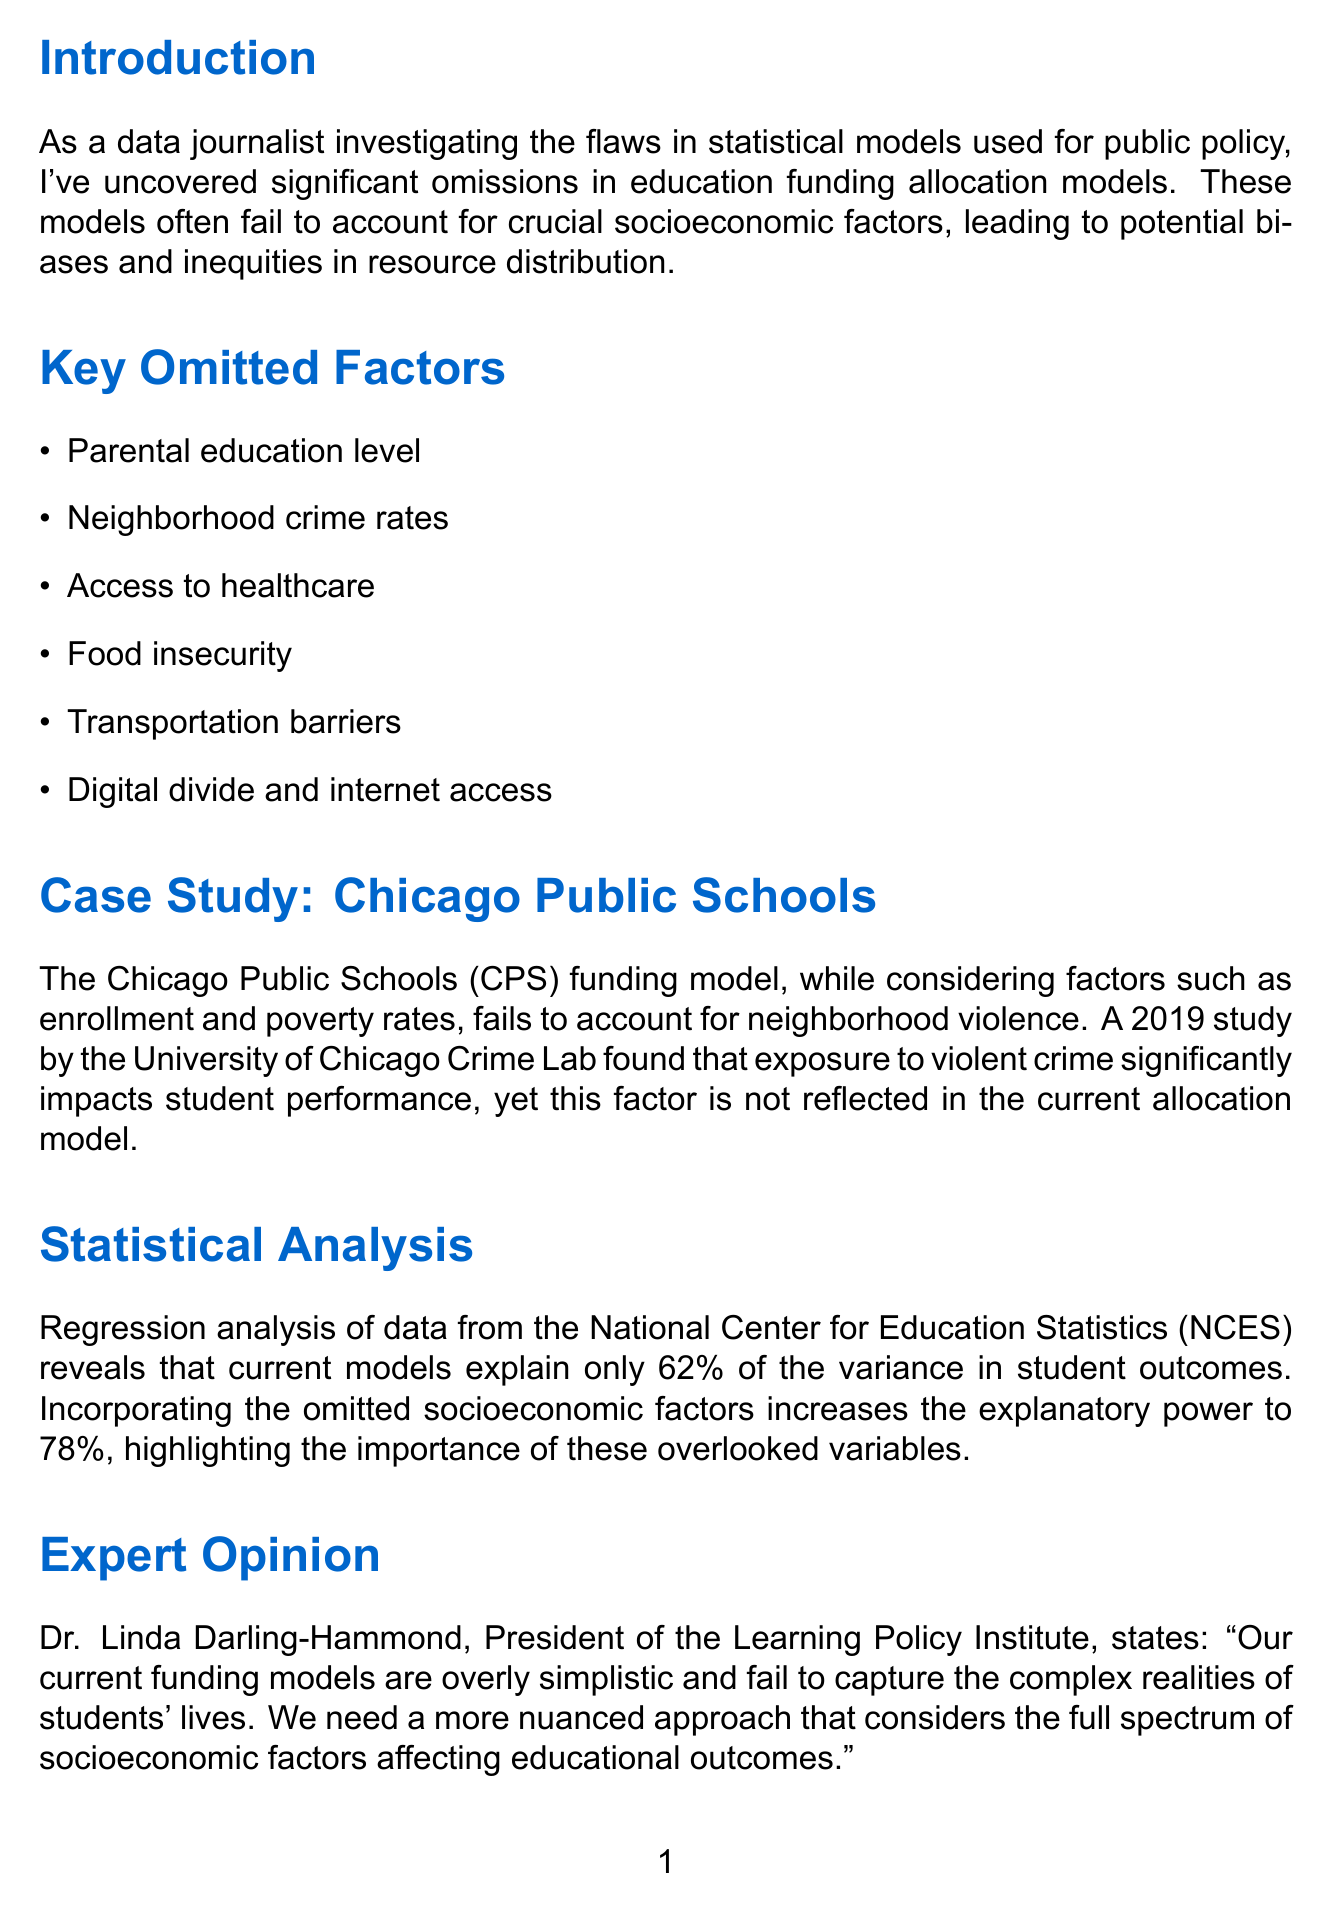what is the title of the document? The title is stated at the top of the document, indicating the main focus of the memo.
Answer: Examination of Socioeconomic Factors Omitted from Education Funding Allocation Models how many key omitted factors are listed? The document enumerates various omitted factors in a specific section, allowing for easy counting.
Answer: Six which case study is presented in the memo? The case study mentioned focuses on a specific educational institution to illustrate the points made.
Answer: Chicago Public Schools what percentage of variance in student outcomes do current models explain? This information is provided in the statistical analysis section of the document, giving a specific evaluation of the models.
Answer: 62% who is the expert quoted in the document? The memo attributes an opinion to a notable authority in education, lending credibility to its claims.
Answer: Dr. Linda Darling-Hammond what is one of the potential impacts of omitted socioeconomic factors mentioned? The document lists various consequences of the omissions, highlighting important issues related to education.
Answer: Perpetuation of educational inequities how many recommendations are listed in the document? The document outlines a series of suggestions to improve funding models, which can be counted.
Answer: Five which country's education funding model is used for international comparison? A specific country is referenced to illustrate a successful approach to funding models.
Answer: Finland 